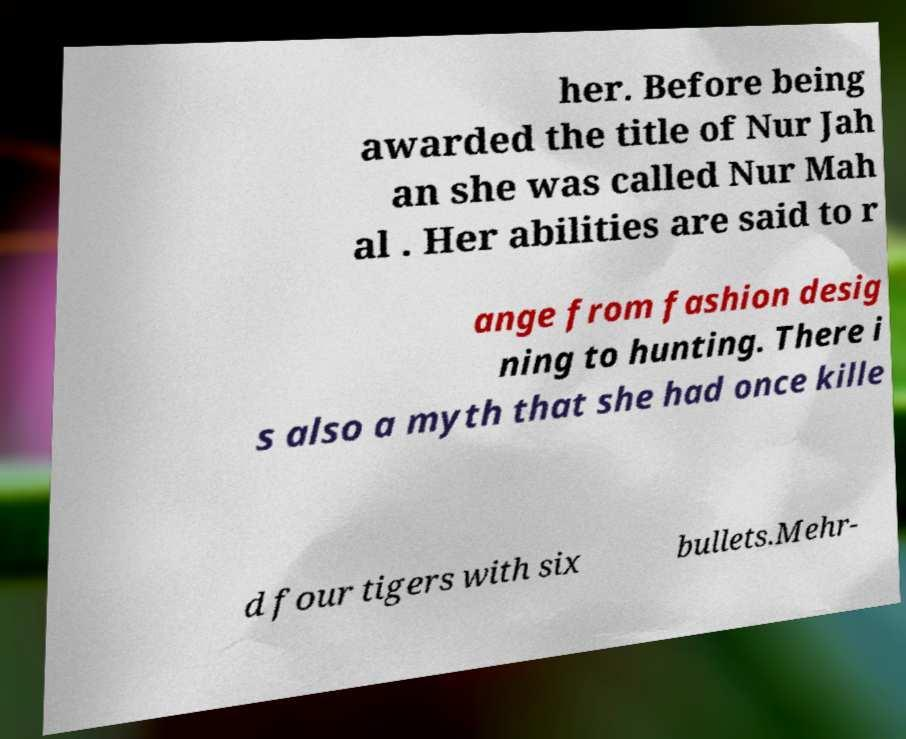I need the written content from this picture converted into text. Can you do that? her. Before being awarded the title of Nur Jah an she was called Nur Mah al . Her abilities are said to r ange from fashion desig ning to hunting. There i s also a myth that she had once kille d four tigers with six bullets.Mehr- 